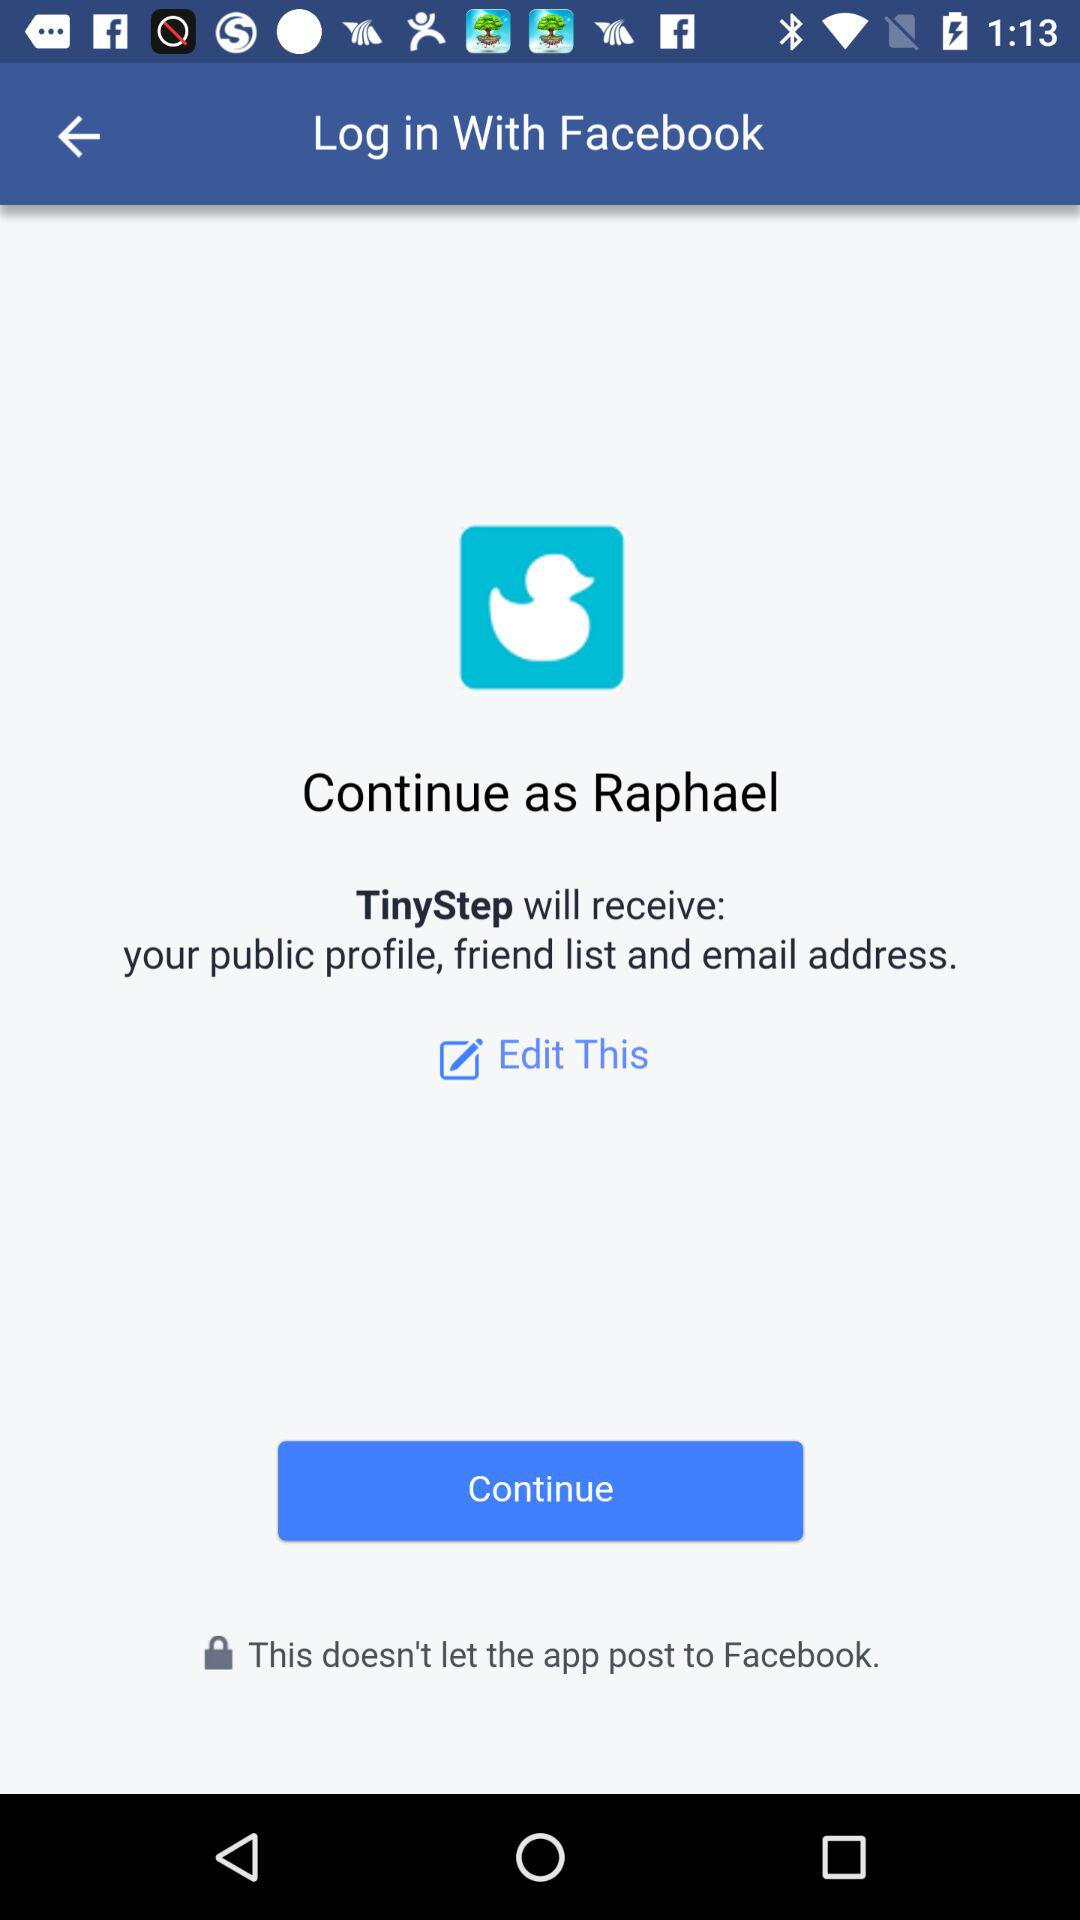What is the name of the user who can continue the application? The name of the user who can continue the application is Raphael. 